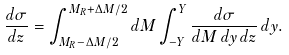<formula> <loc_0><loc_0><loc_500><loc_500>\frac { d \sigma } { d z } = \int _ { M _ { R } - \Delta M / 2 } ^ { M _ { R } + \Delta M / 2 } d M \int _ { - Y } ^ { Y } \frac { d \sigma } { d M \, d y \, d z } \, d y .</formula> 